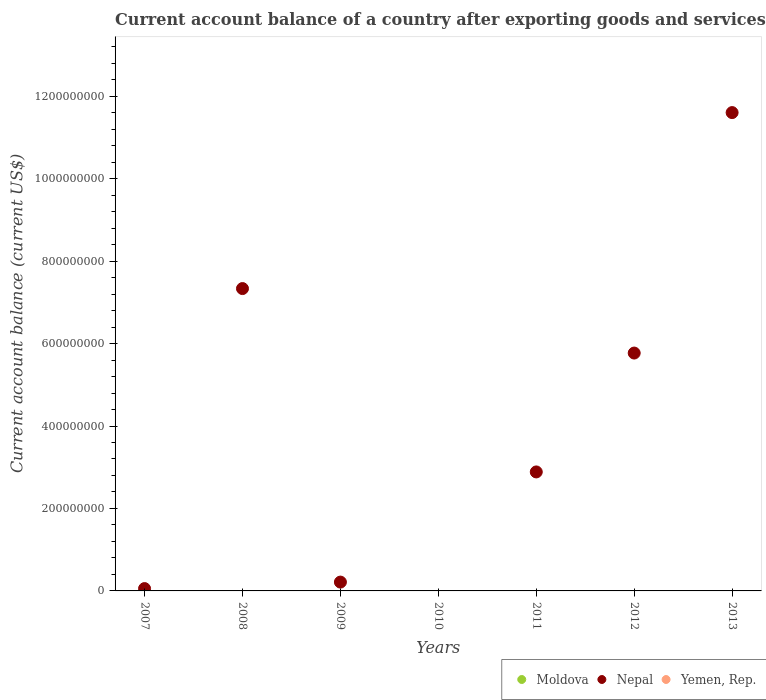How many different coloured dotlines are there?
Make the answer very short. 1. What is the account balance in Yemen, Rep. in 2008?
Give a very brief answer. 0. Across all years, what is the maximum account balance in Nepal?
Make the answer very short. 1.16e+09. In which year was the account balance in Nepal maximum?
Offer a very short reply. 2013. What is the difference between the account balance in Nepal in 2009 and that in 2013?
Keep it short and to the point. -1.14e+09. In how many years, is the account balance in Yemen, Rep. greater than 920000000 US$?
Your answer should be very brief. 0. What is the ratio of the account balance in Nepal in 2008 to that in 2013?
Your response must be concise. 0.63. What is the difference between the highest and the second highest account balance in Nepal?
Offer a terse response. 4.27e+08. In how many years, is the account balance in Yemen, Rep. greater than the average account balance in Yemen, Rep. taken over all years?
Provide a short and direct response. 0. How many dotlines are there?
Your response must be concise. 1. How many years are there in the graph?
Ensure brevity in your answer.  7. Does the graph contain grids?
Provide a short and direct response. No. How many legend labels are there?
Provide a short and direct response. 3. What is the title of the graph?
Ensure brevity in your answer.  Current account balance of a country after exporting goods and services. Does "Niger" appear as one of the legend labels in the graph?
Provide a short and direct response. No. What is the label or title of the Y-axis?
Make the answer very short. Current account balance (current US$). What is the Current account balance (current US$) of Moldova in 2007?
Your response must be concise. 0. What is the Current account balance (current US$) in Nepal in 2007?
Your answer should be very brief. 5.66e+06. What is the Current account balance (current US$) of Yemen, Rep. in 2007?
Make the answer very short. 0. What is the Current account balance (current US$) of Nepal in 2008?
Your answer should be compact. 7.33e+08. What is the Current account balance (current US$) in Yemen, Rep. in 2008?
Make the answer very short. 0. What is the Current account balance (current US$) in Nepal in 2009?
Your answer should be compact. 2.14e+07. What is the Current account balance (current US$) of Moldova in 2010?
Ensure brevity in your answer.  0. What is the Current account balance (current US$) of Nepal in 2010?
Your answer should be very brief. 0. What is the Current account balance (current US$) in Yemen, Rep. in 2010?
Make the answer very short. 0. What is the Current account balance (current US$) of Nepal in 2011?
Your answer should be compact. 2.89e+08. What is the Current account balance (current US$) of Moldova in 2012?
Provide a succinct answer. 0. What is the Current account balance (current US$) in Nepal in 2012?
Give a very brief answer. 5.77e+08. What is the Current account balance (current US$) in Moldova in 2013?
Make the answer very short. 0. What is the Current account balance (current US$) of Nepal in 2013?
Make the answer very short. 1.16e+09. Across all years, what is the maximum Current account balance (current US$) of Nepal?
Your response must be concise. 1.16e+09. What is the total Current account balance (current US$) in Nepal in the graph?
Your answer should be very brief. 2.79e+09. What is the difference between the Current account balance (current US$) of Nepal in 2007 and that in 2008?
Your response must be concise. -7.28e+08. What is the difference between the Current account balance (current US$) in Nepal in 2007 and that in 2009?
Your response must be concise. -1.58e+07. What is the difference between the Current account balance (current US$) in Nepal in 2007 and that in 2011?
Provide a short and direct response. -2.83e+08. What is the difference between the Current account balance (current US$) of Nepal in 2007 and that in 2012?
Provide a short and direct response. -5.71e+08. What is the difference between the Current account balance (current US$) in Nepal in 2007 and that in 2013?
Keep it short and to the point. -1.15e+09. What is the difference between the Current account balance (current US$) of Nepal in 2008 and that in 2009?
Your response must be concise. 7.12e+08. What is the difference between the Current account balance (current US$) in Nepal in 2008 and that in 2011?
Give a very brief answer. 4.45e+08. What is the difference between the Current account balance (current US$) of Nepal in 2008 and that in 2012?
Make the answer very short. 1.56e+08. What is the difference between the Current account balance (current US$) in Nepal in 2008 and that in 2013?
Your answer should be very brief. -4.27e+08. What is the difference between the Current account balance (current US$) of Nepal in 2009 and that in 2011?
Offer a terse response. -2.67e+08. What is the difference between the Current account balance (current US$) in Nepal in 2009 and that in 2012?
Your answer should be compact. -5.56e+08. What is the difference between the Current account balance (current US$) of Nepal in 2009 and that in 2013?
Offer a very short reply. -1.14e+09. What is the difference between the Current account balance (current US$) of Nepal in 2011 and that in 2012?
Ensure brevity in your answer.  -2.88e+08. What is the difference between the Current account balance (current US$) of Nepal in 2011 and that in 2013?
Make the answer very short. -8.72e+08. What is the difference between the Current account balance (current US$) of Nepal in 2012 and that in 2013?
Your response must be concise. -5.83e+08. What is the average Current account balance (current US$) in Moldova per year?
Provide a succinct answer. 0. What is the average Current account balance (current US$) in Nepal per year?
Give a very brief answer. 3.98e+08. What is the average Current account balance (current US$) of Yemen, Rep. per year?
Your answer should be very brief. 0. What is the ratio of the Current account balance (current US$) in Nepal in 2007 to that in 2008?
Offer a terse response. 0.01. What is the ratio of the Current account balance (current US$) of Nepal in 2007 to that in 2009?
Make the answer very short. 0.26. What is the ratio of the Current account balance (current US$) in Nepal in 2007 to that in 2011?
Ensure brevity in your answer.  0.02. What is the ratio of the Current account balance (current US$) in Nepal in 2007 to that in 2012?
Keep it short and to the point. 0.01. What is the ratio of the Current account balance (current US$) of Nepal in 2007 to that in 2013?
Provide a succinct answer. 0. What is the ratio of the Current account balance (current US$) in Nepal in 2008 to that in 2009?
Offer a terse response. 34.25. What is the ratio of the Current account balance (current US$) of Nepal in 2008 to that in 2011?
Your answer should be compact. 2.54. What is the ratio of the Current account balance (current US$) of Nepal in 2008 to that in 2012?
Give a very brief answer. 1.27. What is the ratio of the Current account balance (current US$) in Nepal in 2008 to that in 2013?
Offer a very short reply. 0.63. What is the ratio of the Current account balance (current US$) of Nepal in 2009 to that in 2011?
Provide a short and direct response. 0.07. What is the ratio of the Current account balance (current US$) in Nepal in 2009 to that in 2012?
Give a very brief answer. 0.04. What is the ratio of the Current account balance (current US$) in Nepal in 2009 to that in 2013?
Offer a terse response. 0.02. What is the ratio of the Current account balance (current US$) of Nepal in 2011 to that in 2012?
Your answer should be very brief. 0.5. What is the ratio of the Current account balance (current US$) of Nepal in 2011 to that in 2013?
Your answer should be compact. 0.25. What is the ratio of the Current account balance (current US$) in Nepal in 2012 to that in 2013?
Your answer should be very brief. 0.5. What is the difference between the highest and the second highest Current account balance (current US$) in Nepal?
Provide a short and direct response. 4.27e+08. What is the difference between the highest and the lowest Current account balance (current US$) in Nepal?
Ensure brevity in your answer.  1.16e+09. 